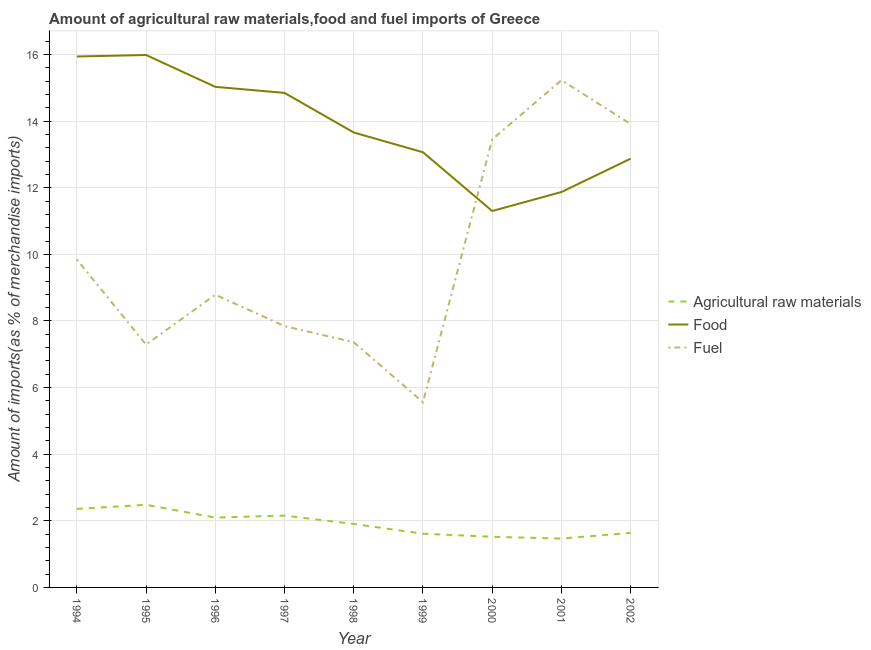What is the percentage of raw materials imports in 1998?
Offer a very short reply. 1.91. Across all years, what is the maximum percentage of raw materials imports?
Keep it short and to the point. 2.48. Across all years, what is the minimum percentage of food imports?
Provide a succinct answer. 11.3. In which year was the percentage of fuel imports maximum?
Keep it short and to the point. 2001. What is the total percentage of raw materials imports in the graph?
Your answer should be compact. 17.24. What is the difference between the percentage of raw materials imports in 1998 and that in 2002?
Your answer should be very brief. 0.27. What is the difference between the percentage of raw materials imports in 1994 and the percentage of fuel imports in 1998?
Your answer should be very brief. -5. What is the average percentage of food imports per year?
Offer a terse response. 13.84. In the year 1997, what is the difference between the percentage of raw materials imports and percentage of fuel imports?
Offer a terse response. -5.69. In how many years, is the percentage of raw materials imports greater than 0.4 %?
Your answer should be very brief. 9. What is the ratio of the percentage of fuel imports in 1996 to that in 2000?
Your answer should be very brief. 0.65. Is the difference between the percentage of raw materials imports in 1998 and 2000 greater than the difference between the percentage of fuel imports in 1998 and 2000?
Give a very brief answer. Yes. What is the difference between the highest and the second highest percentage of fuel imports?
Ensure brevity in your answer.  1.31. What is the difference between the highest and the lowest percentage of food imports?
Your answer should be very brief. 4.68. Is the sum of the percentage of food imports in 1994 and 1997 greater than the maximum percentage of raw materials imports across all years?
Give a very brief answer. Yes. Is the percentage of fuel imports strictly less than the percentage of raw materials imports over the years?
Offer a terse response. No. What is the difference between two consecutive major ticks on the Y-axis?
Keep it short and to the point. 2. Where does the legend appear in the graph?
Keep it short and to the point. Center right. How many legend labels are there?
Give a very brief answer. 3. What is the title of the graph?
Give a very brief answer. Amount of agricultural raw materials,food and fuel imports of Greece. What is the label or title of the X-axis?
Offer a very short reply. Year. What is the label or title of the Y-axis?
Offer a very short reply. Amount of imports(as % of merchandise imports). What is the Amount of imports(as % of merchandise imports) of Agricultural raw materials in 1994?
Offer a terse response. 2.36. What is the Amount of imports(as % of merchandise imports) of Food in 1994?
Make the answer very short. 15.94. What is the Amount of imports(as % of merchandise imports) of Fuel in 1994?
Give a very brief answer. 9.85. What is the Amount of imports(as % of merchandise imports) of Agricultural raw materials in 1995?
Give a very brief answer. 2.48. What is the Amount of imports(as % of merchandise imports) in Food in 1995?
Make the answer very short. 15.99. What is the Amount of imports(as % of merchandise imports) of Fuel in 1995?
Offer a terse response. 7.29. What is the Amount of imports(as % of merchandise imports) of Agricultural raw materials in 1996?
Your response must be concise. 2.1. What is the Amount of imports(as % of merchandise imports) in Food in 1996?
Keep it short and to the point. 15.03. What is the Amount of imports(as % of merchandise imports) in Fuel in 1996?
Provide a succinct answer. 8.79. What is the Amount of imports(as % of merchandise imports) of Agricultural raw materials in 1997?
Make the answer very short. 2.16. What is the Amount of imports(as % of merchandise imports) of Food in 1997?
Your response must be concise. 14.85. What is the Amount of imports(as % of merchandise imports) in Fuel in 1997?
Offer a terse response. 7.85. What is the Amount of imports(as % of merchandise imports) of Agricultural raw materials in 1998?
Give a very brief answer. 1.91. What is the Amount of imports(as % of merchandise imports) of Food in 1998?
Give a very brief answer. 13.66. What is the Amount of imports(as % of merchandise imports) of Fuel in 1998?
Ensure brevity in your answer.  7.36. What is the Amount of imports(as % of merchandise imports) of Agricultural raw materials in 1999?
Your answer should be very brief. 1.61. What is the Amount of imports(as % of merchandise imports) of Food in 1999?
Provide a short and direct response. 13.07. What is the Amount of imports(as % of merchandise imports) in Fuel in 1999?
Your answer should be compact. 5.56. What is the Amount of imports(as % of merchandise imports) in Agricultural raw materials in 2000?
Provide a succinct answer. 1.52. What is the Amount of imports(as % of merchandise imports) in Food in 2000?
Your answer should be compact. 11.3. What is the Amount of imports(as % of merchandise imports) of Fuel in 2000?
Provide a succinct answer. 13.45. What is the Amount of imports(as % of merchandise imports) in Agricultural raw materials in 2001?
Your response must be concise. 1.47. What is the Amount of imports(as % of merchandise imports) in Food in 2001?
Make the answer very short. 11.87. What is the Amount of imports(as % of merchandise imports) in Fuel in 2001?
Your response must be concise. 15.23. What is the Amount of imports(as % of merchandise imports) in Agricultural raw materials in 2002?
Your response must be concise. 1.64. What is the Amount of imports(as % of merchandise imports) of Food in 2002?
Your answer should be compact. 12.87. What is the Amount of imports(as % of merchandise imports) in Fuel in 2002?
Ensure brevity in your answer.  13.91. Across all years, what is the maximum Amount of imports(as % of merchandise imports) in Agricultural raw materials?
Your answer should be very brief. 2.48. Across all years, what is the maximum Amount of imports(as % of merchandise imports) of Food?
Offer a very short reply. 15.99. Across all years, what is the maximum Amount of imports(as % of merchandise imports) of Fuel?
Provide a short and direct response. 15.23. Across all years, what is the minimum Amount of imports(as % of merchandise imports) of Agricultural raw materials?
Keep it short and to the point. 1.47. Across all years, what is the minimum Amount of imports(as % of merchandise imports) in Food?
Your answer should be compact. 11.3. Across all years, what is the minimum Amount of imports(as % of merchandise imports) in Fuel?
Your answer should be very brief. 5.56. What is the total Amount of imports(as % of merchandise imports) of Agricultural raw materials in the graph?
Your answer should be very brief. 17.24. What is the total Amount of imports(as % of merchandise imports) of Food in the graph?
Your answer should be very brief. 124.58. What is the total Amount of imports(as % of merchandise imports) of Fuel in the graph?
Your answer should be compact. 89.29. What is the difference between the Amount of imports(as % of merchandise imports) of Agricultural raw materials in 1994 and that in 1995?
Make the answer very short. -0.12. What is the difference between the Amount of imports(as % of merchandise imports) in Food in 1994 and that in 1995?
Your response must be concise. -0.04. What is the difference between the Amount of imports(as % of merchandise imports) of Fuel in 1994 and that in 1995?
Ensure brevity in your answer.  2.56. What is the difference between the Amount of imports(as % of merchandise imports) in Agricultural raw materials in 1994 and that in 1996?
Give a very brief answer. 0.26. What is the difference between the Amount of imports(as % of merchandise imports) of Food in 1994 and that in 1996?
Your response must be concise. 0.91. What is the difference between the Amount of imports(as % of merchandise imports) of Fuel in 1994 and that in 1996?
Make the answer very short. 1.06. What is the difference between the Amount of imports(as % of merchandise imports) of Agricultural raw materials in 1994 and that in 1997?
Provide a short and direct response. 0.2. What is the difference between the Amount of imports(as % of merchandise imports) in Food in 1994 and that in 1997?
Your answer should be compact. 1.09. What is the difference between the Amount of imports(as % of merchandise imports) in Fuel in 1994 and that in 1997?
Your answer should be very brief. 2. What is the difference between the Amount of imports(as % of merchandise imports) of Agricultural raw materials in 1994 and that in 1998?
Your response must be concise. 0.45. What is the difference between the Amount of imports(as % of merchandise imports) in Food in 1994 and that in 1998?
Your answer should be compact. 2.28. What is the difference between the Amount of imports(as % of merchandise imports) in Fuel in 1994 and that in 1998?
Ensure brevity in your answer.  2.49. What is the difference between the Amount of imports(as % of merchandise imports) of Agricultural raw materials in 1994 and that in 1999?
Make the answer very short. 0.74. What is the difference between the Amount of imports(as % of merchandise imports) of Food in 1994 and that in 1999?
Your answer should be very brief. 2.87. What is the difference between the Amount of imports(as % of merchandise imports) in Fuel in 1994 and that in 1999?
Make the answer very short. 4.29. What is the difference between the Amount of imports(as % of merchandise imports) in Agricultural raw materials in 1994 and that in 2000?
Provide a short and direct response. 0.84. What is the difference between the Amount of imports(as % of merchandise imports) of Food in 1994 and that in 2000?
Give a very brief answer. 4.64. What is the difference between the Amount of imports(as % of merchandise imports) in Fuel in 1994 and that in 2000?
Ensure brevity in your answer.  -3.6. What is the difference between the Amount of imports(as % of merchandise imports) of Agricultural raw materials in 1994 and that in 2001?
Keep it short and to the point. 0.89. What is the difference between the Amount of imports(as % of merchandise imports) in Food in 1994 and that in 2001?
Offer a very short reply. 4.07. What is the difference between the Amount of imports(as % of merchandise imports) in Fuel in 1994 and that in 2001?
Provide a succinct answer. -5.38. What is the difference between the Amount of imports(as % of merchandise imports) of Agricultural raw materials in 1994 and that in 2002?
Provide a short and direct response. 0.72. What is the difference between the Amount of imports(as % of merchandise imports) of Food in 1994 and that in 2002?
Provide a short and direct response. 3.07. What is the difference between the Amount of imports(as % of merchandise imports) in Fuel in 1994 and that in 2002?
Your response must be concise. -4.07. What is the difference between the Amount of imports(as % of merchandise imports) in Agricultural raw materials in 1995 and that in 1996?
Your answer should be very brief. 0.39. What is the difference between the Amount of imports(as % of merchandise imports) of Food in 1995 and that in 1996?
Your answer should be compact. 0.96. What is the difference between the Amount of imports(as % of merchandise imports) of Fuel in 1995 and that in 1996?
Keep it short and to the point. -1.5. What is the difference between the Amount of imports(as % of merchandise imports) of Agricultural raw materials in 1995 and that in 1997?
Offer a terse response. 0.32. What is the difference between the Amount of imports(as % of merchandise imports) in Food in 1995 and that in 1997?
Offer a terse response. 1.14. What is the difference between the Amount of imports(as % of merchandise imports) of Fuel in 1995 and that in 1997?
Your answer should be compact. -0.56. What is the difference between the Amount of imports(as % of merchandise imports) in Agricultural raw materials in 1995 and that in 1998?
Offer a terse response. 0.58. What is the difference between the Amount of imports(as % of merchandise imports) of Food in 1995 and that in 1998?
Offer a terse response. 2.33. What is the difference between the Amount of imports(as % of merchandise imports) of Fuel in 1995 and that in 1998?
Make the answer very short. -0.07. What is the difference between the Amount of imports(as % of merchandise imports) of Agricultural raw materials in 1995 and that in 1999?
Offer a very short reply. 0.87. What is the difference between the Amount of imports(as % of merchandise imports) in Food in 1995 and that in 1999?
Your answer should be very brief. 2.92. What is the difference between the Amount of imports(as % of merchandise imports) in Fuel in 1995 and that in 1999?
Your answer should be very brief. 1.73. What is the difference between the Amount of imports(as % of merchandise imports) of Agricultural raw materials in 1995 and that in 2000?
Your answer should be compact. 0.96. What is the difference between the Amount of imports(as % of merchandise imports) in Food in 1995 and that in 2000?
Your answer should be very brief. 4.68. What is the difference between the Amount of imports(as % of merchandise imports) of Fuel in 1995 and that in 2000?
Provide a succinct answer. -6.16. What is the difference between the Amount of imports(as % of merchandise imports) of Agricultural raw materials in 1995 and that in 2001?
Your answer should be compact. 1.01. What is the difference between the Amount of imports(as % of merchandise imports) of Food in 1995 and that in 2001?
Your answer should be compact. 4.11. What is the difference between the Amount of imports(as % of merchandise imports) of Fuel in 1995 and that in 2001?
Your response must be concise. -7.94. What is the difference between the Amount of imports(as % of merchandise imports) in Agricultural raw materials in 1995 and that in 2002?
Offer a very short reply. 0.84. What is the difference between the Amount of imports(as % of merchandise imports) of Food in 1995 and that in 2002?
Your answer should be compact. 3.11. What is the difference between the Amount of imports(as % of merchandise imports) of Fuel in 1995 and that in 2002?
Your response must be concise. -6.62. What is the difference between the Amount of imports(as % of merchandise imports) in Agricultural raw materials in 1996 and that in 1997?
Provide a succinct answer. -0.06. What is the difference between the Amount of imports(as % of merchandise imports) in Food in 1996 and that in 1997?
Your answer should be compact. 0.18. What is the difference between the Amount of imports(as % of merchandise imports) in Fuel in 1996 and that in 1997?
Offer a very short reply. 0.94. What is the difference between the Amount of imports(as % of merchandise imports) in Agricultural raw materials in 1996 and that in 1998?
Provide a succinct answer. 0.19. What is the difference between the Amount of imports(as % of merchandise imports) of Food in 1996 and that in 1998?
Your answer should be very brief. 1.37. What is the difference between the Amount of imports(as % of merchandise imports) of Fuel in 1996 and that in 1998?
Your answer should be very brief. 1.43. What is the difference between the Amount of imports(as % of merchandise imports) in Agricultural raw materials in 1996 and that in 1999?
Offer a terse response. 0.48. What is the difference between the Amount of imports(as % of merchandise imports) in Food in 1996 and that in 1999?
Your response must be concise. 1.96. What is the difference between the Amount of imports(as % of merchandise imports) in Fuel in 1996 and that in 1999?
Your answer should be very brief. 3.23. What is the difference between the Amount of imports(as % of merchandise imports) of Agricultural raw materials in 1996 and that in 2000?
Your answer should be very brief. 0.58. What is the difference between the Amount of imports(as % of merchandise imports) of Food in 1996 and that in 2000?
Ensure brevity in your answer.  3.73. What is the difference between the Amount of imports(as % of merchandise imports) in Fuel in 1996 and that in 2000?
Make the answer very short. -4.66. What is the difference between the Amount of imports(as % of merchandise imports) of Agricultural raw materials in 1996 and that in 2001?
Your answer should be very brief. 0.63. What is the difference between the Amount of imports(as % of merchandise imports) of Food in 1996 and that in 2001?
Ensure brevity in your answer.  3.16. What is the difference between the Amount of imports(as % of merchandise imports) in Fuel in 1996 and that in 2001?
Offer a very short reply. -6.44. What is the difference between the Amount of imports(as % of merchandise imports) in Agricultural raw materials in 1996 and that in 2002?
Ensure brevity in your answer.  0.46. What is the difference between the Amount of imports(as % of merchandise imports) of Food in 1996 and that in 2002?
Provide a succinct answer. 2.16. What is the difference between the Amount of imports(as % of merchandise imports) in Fuel in 1996 and that in 2002?
Your response must be concise. -5.12. What is the difference between the Amount of imports(as % of merchandise imports) in Agricultural raw materials in 1997 and that in 1998?
Offer a very short reply. 0.25. What is the difference between the Amount of imports(as % of merchandise imports) in Food in 1997 and that in 1998?
Your answer should be compact. 1.19. What is the difference between the Amount of imports(as % of merchandise imports) of Fuel in 1997 and that in 1998?
Your answer should be very brief. 0.48. What is the difference between the Amount of imports(as % of merchandise imports) of Agricultural raw materials in 1997 and that in 1999?
Offer a terse response. 0.54. What is the difference between the Amount of imports(as % of merchandise imports) of Food in 1997 and that in 1999?
Provide a short and direct response. 1.78. What is the difference between the Amount of imports(as % of merchandise imports) in Fuel in 1997 and that in 1999?
Your response must be concise. 2.29. What is the difference between the Amount of imports(as % of merchandise imports) of Agricultural raw materials in 1997 and that in 2000?
Offer a very short reply. 0.64. What is the difference between the Amount of imports(as % of merchandise imports) of Food in 1997 and that in 2000?
Keep it short and to the point. 3.55. What is the difference between the Amount of imports(as % of merchandise imports) in Fuel in 1997 and that in 2000?
Provide a short and direct response. -5.61. What is the difference between the Amount of imports(as % of merchandise imports) in Agricultural raw materials in 1997 and that in 2001?
Your answer should be compact. 0.69. What is the difference between the Amount of imports(as % of merchandise imports) of Food in 1997 and that in 2001?
Ensure brevity in your answer.  2.98. What is the difference between the Amount of imports(as % of merchandise imports) in Fuel in 1997 and that in 2001?
Make the answer very short. -7.38. What is the difference between the Amount of imports(as % of merchandise imports) of Agricultural raw materials in 1997 and that in 2002?
Ensure brevity in your answer.  0.52. What is the difference between the Amount of imports(as % of merchandise imports) in Food in 1997 and that in 2002?
Your answer should be compact. 1.97. What is the difference between the Amount of imports(as % of merchandise imports) in Fuel in 1997 and that in 2002?
Your answer should be very brief. -6.07. What is the difference between the Amount of imports(as % of merchandise imports) in Agricultural raw materials in 1998 and that in 1999?
Offer a terse response. 0.29. What is the difference between the Amount of imports(as % of merchandise imports) in Food in 1998 and that in 1999?
Make the answer very short. 0.59. What is the difference between the Amount of imports(as % of merchandise imports) of Fuel in 1998 and that in 1999?
Your response must be concise. 1.8. What is the difference between the Amount of imports(as % of merchandise imports) of Agricultural raw materials in 1998 and that in 2000?
Offer a terse response. 0.38. What is the difference between the Amount of imports(as % of merchandise imports) of Food in 1998 and that in 2000?
Provide a short and direct response. 2.36. What is the difference between the Amount of imports(as % of merchandise imports) of Fuel in 1998 and that in 2000?
Your answer should be very brief. -6.09. What is the difference between the Amount of imports(as % of merchandise imports) in Agricultural raw materials in 1998 and that in 2001?
Provide a succinct answer. 0.44. What is the difference between the Amount of imports(as % of merchandise imports) in Food in 1998 and that in 2001?
Your answer should be compact. 1.79. What is the difference between the Amount of imports(as % of merchandise imports) in Fuel in 1998 and that in 2001?
Your answer should be very brief. -7.87. What is the difference between the Amount of imports(as % of merchandise imports) of Agricultural raw materials in 1998 and that in 2002?
Provide a short and direct response. 0.27. What is the difference between the Amount of imports(as % of merchandise imports) in Food in 1998 and that in 2002?
Keep it short and to the point. 0.79. What is the difference between the Amount of imports(as % of merchandise imports) in Fuel in 1998 and that in 2002?
Your response must be concise. -6.55. What is the difference between the Amount of imports(as % of merchandise imports) in Agricultural raw materials in 1999 and that in 2000?
Give a very brief answer. 0.09. What is the difference between the Amount of imports(as % of merchandise imports) in Food in 1999 and that in 2000?
Your response must be concise. 1.77. What is the difference between the Amount of imports(as % of merchandise imports) in Fuel in 1999 and that in 2000?
Give a very brief answer. -7.89. What is the difference between the Amount of imports(as % of merchandise imports) of Agricultural raw materials in 1999 and that in 2001?
Your response must be concise. 0.15. What is the difference between the Amount of imports(as % of merchandise imports) in Food in 1999 and that in 2001?
Your answer should be compact. 1.19. What is the difference between the Amount of imports(as % of merchandise imports) of Fuel in 1999 and that in 2001?
Give a very brief answer. -9.67. What is the difference between the Amount of imports(as % of merchandise imports) in Agricultural raw materials in 1999 and that in 2002?
Offer a terse response. -0.02. What is the difference between the Amount of imports(as % of merchandise imports) in Food in 1999 and that in 2002?
Make the answer very short. 0.19. What is the difference between the Amount of imports(as % of merchandise imports) in Fuel in 1999 and that in 2002?
Your response must be concise. -8.36. What is the difference between the Amount of imports(as % of merchandise imports) in Agricultural raw materials in 2000 and that in 2001?
Ensure brevity in your answer.  0.05. What is the difference between the Amount of imports(as % of merchandise imports) in Food in 2000 and that in 2001?
Your response must be concise. -0.57. What is the difference between the Amount of imports(as % of merchandise imports) in Fuel in 2000 and that in 2001?
Provide a short and direct response. -1.78. What is the difference between the Amount of imports(as % of merchandise imports) of Agricultural raw materials in 2000 and that in 2002?
Ensure brevity in your answer.  -0.12. What is the difference between the Amount of imports(as % of merchandise imports) of Food in 2000 and that in 2002?
Make the answer very short. -1.57. What is the difference between the Amount of imports(as % of merchandise imports) in Fuel in 2000 and that in 2002?
Your answer should be very brief. -0.46. What is the difference between the Amount of imports(as % of merchandise imports) of Agricultural raw materials in 2001 and that in 2002?
Provide a short and direct response. -0.17. What is the difference between the Amount of imports(as % of merchandise imports) of Food in 2001 and that in 2002?
Make the answer very short. -1. What is the difference between the Amount of imports(as % of merchandise imports) of Fuel in 2001 and that in 2002?
Keep it short and to the point. 1.31. What is the difference between the Amount of imports(as % of merchandise imports) in Agricultural raw materials in 1994 and the Amount of imports(as % of merchandise imports) in Food in 1995?
Provide a short and direct response. -13.63. What is the difference between the Amount of imports(as % of merchandise imports) in Agricultural raw materials in 1994 and the Amount of imports(as % of merchandise imports) in Fuel in 1995?
Your answer should be compact. -4.93. What is the difference between the Amount of imports(as % of merchandise imports) of Food in 1994 and the Amount of imports(as % of merchandise imports) of Fuel in 1995?
Give a very brief answer. 8.65. What is the difference between the Amount of imports(as % of merchandise imports) of Agricultural raw materials in 1994 and the Amount of imports(as % of merchandise imports) of Food in 1996?
Give a very brief answer. -12.67. What is the difference between the Amount of imports(as % of merchandise imports) of Agricultural raw materials in 1994 and the Amount of imports(as % of merchandise imports) of Fuel in 1996?
Your answer should be compact. -6.43. What is the difference between the Amount of imports(as % of merchandise imports) in Food in 1994 and the Amount of imports(as % of merchandise imports) in Fuel in 1996?
Your answer should be compact. 7.15. What is the difference between the Amount of imports(as % of merchandise imports) in Agricultural raw materials in 1994 and the Amount of imports(as % of merchandise imports) in Food in 1997?
Provide a succinct answer. -12.49. What is the difference between the Amount of imports(as % of merchandise imports) of Agricultural raw materials in 1994 and the Amount of imports(as % of merchandise imports) of Fuel in 1997?
Give a very brief answer. -5.49. What is the difference between the Amount of imports(as % of merchandise imports) in Food in 1994 and the Amount of imports(as % of merchandise imports) in Fuel in 1997?
Your response must be concise. 8.1. What is the difference between the Amount of imports(as % of merchandise imports) of Agricultural raw materials in 1994 and the Amount of imports(as % of merchandise imports) of Food in 1998?
Provide a short and direct response. -11.3. What is the difference between the Amount of imports(as % of merchandise imports) of Agricultural raw materials in 1994 and the Amount of imports(as % of merchandise imports) of Fuel in 1998?
Offer a very short reply. -5. What is the difference between the Amount of imports(as % of merchandise imports) of Food in 1994 and the Amount of imports(as % of merchandise imports) of Fuel in 1998?
Give a very brief answer. 8.58. What is the difference between the Amount of imports(as % of merchandise imports) in Agricultural raw materials in 1994 and the Amount of imports(as % of merchandise imports) in Food in 1999?
Your answer should be very brief. -10.71. What is the difference between the Amount of imports(as % of merchandise imports) of Agricultural raw materials in 1994 and the Amount of imports(as % of merchandise imports) of Fuel in 1999?
Keep it short and to the point. -3.2. What is the difference between the Amount of imports(as % of merchandise imports) of Food in 1994 and the Amount of imports(as % of merchandise imports) of Fuel in 1999?
Keep it short and to the point. 10.38. What is the difference between the Amount of imports(as % of merchandise imports) in Agricultural raw materials in 1994 and the Amount of imports(as % of merchandise imports) in Food in 2000?
Make the answer very short. -8.94. What is the difference between the Amount of imports(as % of merchandise imports) in Agricultural raw materials in 1994 and the Amount of imports(as % of merchandise imports) in Fuel in 2000?
Your answer should be very brief. -11.1. What is the difference between the Amount of imports(as % of merchandise imports) in Food in 1994 and the Amount of imports(as % of merchandise imports) in Fuel in 2000?
Offer a terse response. 2.49. What is the difference between the Amount of imports(as % of merchandise imports) in Agricultural raw materials in 1994 and the Amount of imports(as % of merchandise imports) in Food in 2001?
Your answer should be very brief. -9.52. What is the difference between the Amount of imports(as % of merchandise imports) in Agricultural raw materials in 1994 and the Amount of imports(as % of merchandise imports) in Fuel in 2001?
Your response must be concise. -12.87. What is the difference between the Amount of imports(as % of merchandise imports) in Food in 1994 and the Amount of imports(as % of merchandise imports) in Fuel in 2001?
Your answer should be very brief. 0.71. What is the difference between the Amount of imports(as % of merchandise imports) of Agricultural raw materials in 1994 and the Amount of imports(as % of merchandise imports) of Food in 2002?
Offer a terse response. -10.52. What is the difference between the Amount of imports(as % of merchandise imports) of Agricultural raw materials in 1994 and the Amount of imports(as % of merchandise imports) of Fuel in 2002?
Offer a very short reply. -11.56. What is the difference between the Amount of imports(as % of merchandise imports) of Food in 1994 and the Amount of imports(as % of merchandise imports) of Fuel in 2002?
Give a very brief answer. 2.03. What is the difference between the Amount of imports(as % of merchandise imports) in Agricultural raw materials in 1995 and the Amount of imports(as % of merchandise imports) in Food in 1996?
Provide a succinct answer. -12.55. What is the difference between the Amount of imports(as % of merchandise imports) of Agricultural raw materials in 1995 and the Amount of imports(as % of merchandise imports) of Fuel in 1996?
Make the answer very short. -6.31. What is the difference between the Amount of imports(as % of merchandise imports) of Food in 1995 and the Amount of imports(as % of merchandise imports) of Fuel in 1996?
Ensure brevity in your answer.  7.2. What is the difference between the Amount of imports(as % of merchandise imports) in Agricultural raw materials in 1995 and the Amount of imports(as % of merchandise imports) in Food in 1997?
Give a very brief answer. -12.37. What is the difference between the Amount of imports(as % of merchandise imports) of Agricultural raw materials in 1995 and the Amount of imports(as % of merchandise imports) of Fuel in 1997?
Provide a succinct answer. -5.36. What is the difference between the Amount of imports(as % of merchandise imports) of Food in 1995 and the Amount of imports(as % of merchandise imports) of Fuel in 1997?
Offer a terse response. 8.14. What is the difference between the Amount of imports(as % of merchandise imports) of Agricultural raw materials in 1995 and the Amount of imports(as % of merchandise imports) of Food in 1998?
Your response must be concise. -11.18. What is the difference between the Amount of imports(as % of merchandise imports) of Agricultural raw materials in 1995 and the Amount of imports(as % of merchandise imports) of Fuel in 1998?
Make the answer very short. -4.88. What is the difference between the Amount of imports(as % of merchandise imports) in Food in 1995 and the Amount of imports(as % of merchandise imports) in Fuel in 1998?
Give a very brief answer. 8.62. What is the difference between the Amount of imports(as % of merchandise imports) of Agricultural raw materials in 1995 and the Amount of imports(as % of merchandise imports) of Food in 1999?
Your answer should be compact. -10.58. What is the difference between the Amount of imports(as % of merchandise imports) in Agricultural raw materials in 1995 and the Amount of imports(as % of merchandise imports) in Fuel in 1999?
Offer a very short reply. -3.08. What is the difference between the Amount of imports(as % of merchandise imports) of Food in 1995 and the Amount of imports(as % of merchandise imports) of Fuel in 1999?
Provide a succinct answer. 10.43. What is the difference between the Amount of imports(as % of merchandise imports) of Agricultural raw materials in 1995 and the Amount of imports(as % of merchandise imports) of Food in 2000?
Make the answer very short. -8.82. What is the difference between the Amount of imports(as % of merchandise imports) in Agricultural raw materials in 1995 and the Amount of imports(as % of merchandise imports) in Fuel in 2000?
Make the answer very short. -10.97. What is the difference between the Amount of imports(as % of merchandise imports) in Food in 1995 and the Amount of imports(as % of merchandise imports) in Fuel in 2000?
Offer a very short reply. 2.53. What is the difference between the Amount of imports(as % of merchandise imports) in Agricultural raw materials in 1995 and the Amount of imports(as % of merchandise imports) in Food in 2001?
Your answer should be compact. -9.39. What is the difference between the Amount of imports(as % of merchandise imports) of Agricultural raw materials in 1995 and the Amount of imports(as % of merchandise imports) of Fuel in 2001?
Provide a succinct answer. -12.75. What is the difference between the Amount of imports(as % of merchandise imports) in Food in 1995 and the Amount of imports(as % of merchandise imports) in Fuel in 2001?
Provide a short and direct response. 0.76. What is the difference between the Amount of imports(as % of merchandise imports) in Agricultural raw materials in 1995 and the Amount of imports(as % of merchandise imports) in Food in 2002?
Ensure brevity in your answer.  -10.39. What is the difference between the Amount of imports(as % of merchandise imports) in Agricultural raw materials in 1995 and the Amount of imports(as % of merchandise imports) in Fuel in 2002?
Provide a short and direct response. -11.43. What is the difference between the Amount of imports(as % of merchandise imports) of Food in 1995 and the Amount of imports(as % of merchandise imports) of Fuel in 2002?
Your answer should be compact. 2.07. What is the difference between the Amount of imports(as % of merchandise imports) in Agricultural raw materials in 1996 and the Amount of imports(as % of merchandise imports) in Food in 1997?
Provide a short and direct response. -12.75. What is the difference between the Amount of imports(as % of merchandise imports) in Agricultural raw materials in 1996 and the Amount of imports(as % of merchandise imports) in Fuel in 1997?
Keep it short and to the point. -5.75. What is the difference between the Amount of imports(as % of merchandise imports) in Food in 1996 and the Amount of imports(as % of merchandise imports) in Fuel in 1997?
Your answer should be very brief. 7.18. What is the difference between the Amount of imports(as % of merchandise imports) of Agricultural raw materials in 1996 and the Amount of imports(as % of merchandise imports) of Food in 1998?
Offer a terse response. -11.56. What is the difference between the Amount of imports(as % of merchandise imports) of Agricultural raw materials in 1996 and the Amount of imports(as % of merchandise imports) of Fuel in 1998?
Provide a short and direct response. -5.26. What is the difference between the Amount of imports(as % of merchandise imports) of Food in 1996 and the Amount of imports(as % of merchandise imports) of Fuel in 1998?
Keep it short and to the point. 7.67. What is the difference between the Amount of imports(as % of merchandise imports) in Agricultural raw materials in 1996 and the Amount of imports(as % of merchandise imports) in Food in 1999?
Your answer should be very brief. -10.97. What is the difference between the Amount of imports(as % of merchandise imports) in Agricultural raw materials in 1996 and the Amount of imports(as % of merchandise imports) in Fuel in 1999?
Offer a very short reply. -3.46. What is the difference between the Amount of imports(as % of merchandise imports) of Food in 1996 and the Amount of imports(as % of merchandise imports) of Fuel in 1999?
Your response must be concise. 9.47. What is the difference between the Amount of imports(as % of merchandise imports) in Agricultural raw materials in 1996 and the Amount of imports(as % of merchandise imports) in Food in 2000?
Your answer should be very brief. -9.2. What is the difference between the Amount of imports(as % of merchandise imports) of Agricultural raw materials in 1996 and the Amount of imports(as % of merchandise imports) of Fuel in 2000?
Give a very brief answer. -11.36. What is the difference between the Amount of imports(as % of merchandise imports) in Food in 1996 and the Amount of imports(as % of merchandise imports) in Fuel in 2000?
Provide a short and direct response. 1.58. What is the difference between the Amount of imports(as % of merchandise imports) in Agricultural raw materials in 1996 and the Amount of imports(as % of merchandise imports) in Food in 2001?
Give a very brief answer. -9.78. What is the difference between the Amount of imports(as % of merchandise imports) of Agricultural raw materials in 1996 and the Amount of imports(as % of merchandise imports) of Fuel in 2001?
Ensure brevity in your answer.  -13.13. What is the difference between the Amount of imports(as % of merchandise imports) of Food in 1996 and the Amount of imports(as % of merchandise imports) of Fuel in 2001?
Ensure brevity in your answer.  -0.2. What is the difference between the Amount of imports(as % of merchandise imports) in Agricultural raw materials in 1996 and the Amount of imports(as % of merchandise imports) in Food in 2002?
Make the answer very short. -10.78. What is the difference between the Amount of imports(as % of merchandise imports) in Agricultural raw materials in 1996 and the Amount of imports(as % of merchandise imports) in Fuel in 2002?
Keep it short and to the point. -11.82. What is the difference between the Amount of imports(as % of merchandise imports) in Food in 1996 and the Amount of imports(as % of merchandise imports) in Fuel in 2002?
Make the answer very short. 1.12. What is the difference between the Amount of imports(as % of merchandise imports) in Agricultural raw materials in 1997 and the Amount of imports(as % of merchandise imports) in Food in 1998?
Offer a very short reply. -11.5. What is the difference between the Amount of imports(as % of merchandise imports) in Agricultural raw materials in 1997 and the Amount of imports(as % of merchandise imports) in Fuel in 1998?
Your response must be concise. -5.2. What is the difference between the Amount of imports(as % of merchandise imports) in Food in 1997 and the Amount of imports(as % of merchandise imports) in Fuel in 1998?
Provide a short and direct response. 7.49. What is the difference between the Amount of imports(as % of merchandise imports) in Agricultural raw materials in 1997 and the Amount of imports(as % of merchandise imports) in Food in 1999?
Make the answer very short. -10.91. What is the difference between the Amount of imports(as % of merchandise imports) in Agricultural raw materials in 1997 and the Amount of imports(as % of merchandise imports) in Fuel in 1999?
Make the answer very short. -3.4. What is the difference between the Amount of imports(as % of merchandise imports) in Food in 1997 and the Amount of imports(as % of merchandise imports) in Fuel in 1999?
Your response must be concise. 9.29. What is the difference between the Amount of imports(as % of merchandise imports) in Agricultural raw materials in 1997 and the Amount of imports(as % of merchandise imports) in Food in 2000?
Your answer should be very brief. -9.14. What is the difference between the Amount of imports(as % of merchandise imports) of Agricultural raw materials in 1997 and the Amount of imports(as % of merchandise imports) of Fuel in 2000?
Ensure brevity in your answer.  -11.3. What is the difference between the Amount of imports(as % of merchandise imports) in Food in 1997 and the Amount of imports(as % of merchandise imports) in Fuel in 2000?
Your response must be concise. 1.4. What is the difference between the Amount of imports(as % of merchandise imports) of Agricultural raw materials in 1997 and the Amount of imports(as % of merchandise imports) of Food in 2001?
Your answer should be compact. -9.72. What is the difference between the Amount of imports(as % of merchandise imports) in Agricultural raw materials in 1997 and the Amount of imports(as % of merchandise imports) in Fuel in 2001?
Your answer should be compact. -13.07. What is the difference between the Amount of imports(as % of merchandise imports) in Food in 1997 and the Amount of imports(as % of merchandise imports) in Fuel in 2001?
Your answer should be compact. -0.38. What is the difference between the Amount of imports(as % of merchandise imports) of Agricultural raw materials in 1997 and the Amount of imports(as % of merchandise imports) of Food in 2002?
Your response must be concise. -10.72. What is the difference between the Amount of imports(as % of merchandise imports) in Agricultural raw materials in 1997 and the Amount of imports(as % of merchandise imports) in Fuel in 2002?
Provide a succinct answer. -11.76. What is the difference between the Amount of imports(as % of merchandise imports) of Food in 1997 and the Amount of imports(as % of merchandise imports) of Fuel in 2002?
Offer a terse response. 0.93. What is the difference between the Amount of imports(as % of merchandise imports) in Agricultural raw materials in 1998 and the Amount of imports(as % of merchandise imports) in Food in 1999?
Your response must be concise. -11.16. What is the difference between the Amount of imports(as % of merchandise imports) in Agricultural raw materials in 1998 and the Amount of imports(as % of merchandise imports) in Fuel in 1999?
Provide a short and direct response. -3.65. What is the difference between the Amount of imports(as % of merchandise imports) in Food in 1998 and the Amount of imports(as % of merchandise imports) in Fuel in 1999?
Your answer should be compact. 8.1. What is the difference between the Amount of imports(as % of merchandise imports) in Agricultural raw materials in 1998 and the Amount of imports(as % of merchandise imports) in Food in 2000?
Offer a very short reply. -9.4. What is the difference between the Amount of imports(as % of merchandise imports) in Agricultural raw materials in 1998 and the Amount of imports(as % of merchandise imports) in Fuel in 2000?
Provide a short and direct response. -11.55. What is the difference between the Amount of imports(as % of merchandise imports) in Food in 1998 and the Amount of imports(as % of merchandise imports) in Fuel in 2000?
Make the answer very short. 0.21. What is the difference between the Amount of imports(as % of merchandise imports) in Agricultural raw materials in 1998 and the Amount of imports(as % of merchandise imports) in Food in 2001?
Provide a short and direct response. -9.97. What is the difference between the Amount of imports(as % of merchandise imports) of Agricultural raw materials in 1998 and the Amount of imports(as % of merchandise imports) of Fuel in 2001?
Your answer should be compact. -13.32. What is the difference between the Amount of imports(as % of merchandise imports) in Food in 1998 and the Amount of imports(as % of merchandise imports) in Fuel in 2001?
Provide a succinct answer. -1.57. What is the difference between the Amount of imports(as % of merchandise imports) of Agricultural raw materials in 1998 and the Amount of imports(as % of merchandise imports) of Food in 2002?
Your response must be concise. -10.97. What is the difference between the Amount of imports(as % of merchandise imports) of Agricultural raw materials in 1998 and the Amount of imports(as % of merchandise imports) of Fuel in 2002?
Provide a short and direct response. -12.01. What is the difference between the Amount of imports(as % of merchandise imports) in Food in 1998 and the Amount of imports(as % of merchandise imports) in Fuel in 2002?
Keep it short and to the point. -0.25. What is the difference between the Amount of imports(as % of merchandise imports) of Agricultural raw materials in 1999 and the Amount of imports(as % of merchandise imports) of Food in 2000?
Offer a terse response. -9.69. What is the difference between the Amount of imports(as % of merchandise imports) of Agricultural raw materials in 1999 and the Amount of imports(as % of merchandise imports) of Fuel in 2000?
Provide a short and direct response. -11.84. What is the difference between the Amount of imports(as % of merchandise imports) in Food in 1999 and the Amount of imports(as % of merchandise imports) in Fuel in 2000?
Keep it short and to the point. -0.39. What is the difference between the Amount of imports(as % of merchandise imports) in Agricultural raw materials in 1999 and the Amount of imports(as % of merchandise imports) in Food in 2001?
Make the answer very short. -10.26. What is the difference between the Amount of imports(as % of merchandise imports) in Agricultural raw materials in 1999 and the Amount of imports(as % of merchandise imports) in Fuel in 2001?
Your answer should be very brief. -13.62. What is the difference between the Amount of imports(as % of merchandise imports) in Food in 1999 and the Amount of imports(as % of merchandise imports) in Fuel in 2001?
Provide a succinct answer. -2.16. What is the difference between the Amount of imports(as % of merchandise imports) of Agricultural raw materials in 1999 and the Amount of imports(as % of merchandise imports) of Food in 2002?
Offer a very short reply. -11.26. What is the difference between the Amount of imports(as % of merchandise imports) of Agricultural raw materials in 1999 and the Amount of imports(as % of merchandise imports) of Fuel in 2002?
Give a very brief answer. -12.3. What is the difference between the Amount of imports(as % of merchandise imports) in Food in 1999 and the Amount of imports(as % of merchandise imports) in Fuel in 2002?
Ensure brevity in your answer.  -0.85. What is the difference between the Amount of imports(as % of merchandise imports) of Agricultural raw materials in 2000 and the Amount of imports(as % of merchandise imports) of Food in 2001?
Offer a very short reply. -10.35. What is the difference between the Amount of imports(as % of merchandise imports) in Agricultural raw materials in 2000 and the Amount of imports(as % of merchandise imports) in Fuel in 2001?
Make the answer very short. -13.71. What is the difference between the Amount of imports(as % of merchandise imports) of Food in 2000 and the Amount of imports(as % of merchandise imports) of Fuel in 2001?
Provide a succinct answer. -3.93. What is the difference between the Amount of imports(as % of merchandise imports) of Agricultural raw materials in 2000 and the Amount of imports(as % of merchandise imports) of Food in 2002?
Give a very brief answer. -11.35. What is the difference between the Amount of imports(as % of merchandise imports) of Agricultural raw materials in 2000 and the Amount of imports(as % of merchandise imports) of Fuel in 2002?
Offer a terse response. -12.39. What is the difference between the Amount of imports(as % of merchandise imports) of Food in 2000 and the Amount of imports(as % of merchandise imports) of Fuel in 2002?
Your answer should be compact. -2.61. What is the difference between the Amount of imports(as % of merchandise imports) of Agricultural raw materials in 2001 and the Amount of imports(as % of merchandise imports) of Food in 2002?
Give a very brief answer. -11.41. What is the difference between the Amount of imports(as % of merchandise imports) in Agricultural raw materials in 2001 and the Amount of imports(as % of merchandise imports) in Fuel in 2002?
Provide a succinct answer. -12.45. What is the difference between the Amount of imports(as % of merchandise imports) in Food in 2001 and the Amount of imports(as % of merchandise imports) in Fuel in 2002?
Your answer should be very brief. -2.04. What is the average Amount of imports(as % of merchandise imports) in Agricultural raw materials per year?
Offer a terse response. 1.92. What is the average Amount of imports(as % of merchandise imports) in Food per year?
Provide a short and direct response. 13.84. What is the average Amount of imports(as % of merchandise imports) of Fuel per year?
Offer a very short reply. 9.92. In the year 1994, what is the difference between the Amount of imports(as % of merchandise imports) in Agricultural raw materials and Amount of imports(as % of merchandise imports) in Food?
Ensure brevity in your answer.  -13.58. In the year 1994, what is the difference between the Amount of imports(as % of merchandise imports) of Agricultural raw materials and Amount of imports(as % of merchandise imports) of Fuel?
Provide a short and direct response. -7.49. In the year 1994, what is the difference between the Amount of imports(as % of merchandise imports) in Food and Amount of imports(as % of merchandise imports) in Fuel?
Make the answer very short. 6.09. In the year 1995, what is the difference between the Amount of imports(as % of merchandise imports) of Agricultural raw materials and Amount of imports(as % of merchandise imports) of Food?
Your answer should be very brief. -13.5. In the year 1995, what is the difference between the Amount of imports(as % of merchandise imports) of Agricultural raw materials and Amount of imports(as % of merchandise imports) of Fuel?
Ensure brevity in your answer.  -4.81. In the year 1995, what is the difference between the Amount of imports(as % of merchandise imports) of Food and Amount of imports(as % of merchandise imports) of Fuel?
Offer a terse response. 8.7. In the year 1996, what is the difference between the Amount of imports(as % of merchandise imports) of Agricultural raw materials and Amount of imports(as % of merchandise imports) of Food?
Offer a very short reply. -12.93. In the year 1996, what is the difference between the Amount of imports(as % of merchandise imports) in Agricultural raw materials and Amount of imports(as % of merchandise imports) in Fuel?
Your answer should be compact. -6.69. In the year 1996, what is the difference between the Amount of imports(as % of merchandise imports) in Food and Amount of imports(as % of merchandise imports) in Fuel?
Give a very brief answer. 6.24. In the year 1997, what is the difference between the Amount of imports(as % of merchandise imports) of Agricultural raw materials and Amount of imports(as % of merchandise imports) of Food?
Your response must be concise. -12.69. In the year 1997, what is the difference between the Amount of imports(as % of merchandise imports) of Agricultural raw materials and Amount of imports(as % of merchandise imports) of Fuel?
Offer a terse response. -5.69. In the year 1997, what is the difference between the Amount of imports(as % of merchandise imports) in Food and Amount of imports(as % of merchandise imports) in Fuel?
Make the answer very short. 7. In the year 1998, what is the difference between the Amount of imports(as % of merchandise imports) of Agricultural raw materials and Amount of imports(as % of merchandise imports) of Food?
Your answer should be very brief. -11.75. In the year 1998, what is the difference between the Amount of imports(as % of merchandise imports) in Agricultural raw materials and Amount of imports(as % of merchandise imports) in Fuel?
Your answer should be very brief. -5.46. In the year 1998, what is the difference between the Amount of imports(as % of merchandise imports) in Food and Amount of imports(as % of merchandise imports) in Fuel?
Ensure brevity in your answer.  6.3. In the year 1999, what is the difference between the Amount of imports(as % of merchandise imports) of Agricultural raw materials and Amount of imports(as % of merchandise imports) of Food?
Provide a succinct answer. -11.45. In the year 1999, what is the difference between the Amount of imports(as % of merchandise imports) of Agricultural raw materials and Amount of imports(as % of merchandise imports) of Fuel?
Give a very brief answer. -3.95. In the year 1999, what is the difference between the Amount of imports(as % of merchandise imports) in Food and Amount of imports(as % of merchandise imports) in Fuel?
Give a very brief answer. 7.51. In the year 2000, what is the difference between the Amount of imports(as % of merchandise imports) in Agricultural raw materials and Amount of imports(as % of merchandise imports) in Food?
Keep it short and to the point. -9.78. In the year 2000, what is the difference between the Amount of imports(as % of merchandise imports) of Agricultural raw materials and Amount of imports(as % of merchandise imports) of Fuel?
Your answer should be very brief. -11.93. In the year 2000, what is the difference between the Amount of imports(as % of merchandise imports) of Food and Amount of imports(as % of merchandise imports) of Fuel?
Provide a short and direct response. -2.15. In the year 2001, what is the difference between the Amount of imports(as % of merchandise imports) in Agricultural raw materials and Amount of imports(as % of merchandise imports) in Food?
Your response must be concise. -10.41. In the year 2001, what is the difference between the Amount of imports(as % of merchandise imports) in Agricultural raw materials and Amount of imports(as % of merchandise imports) in Fuel?
Your response must be concise. -13.76. In the year 2001, what is the difference between the Amount of imports(as % of merchandise imports) in Food and Amount of imports(as % of merchandise imports) in Fuel?
Offer a terse response. -3.36. In the year 2002, what is the difference between the Amount of imports(as % of merchandise imports) in Agricultural raw materials and Amount of imports(as % of merchandise imports) in Food?
Your answer should be very brief. -11.24. In the year 2002, what is the difference between the Amount of imports(as % of merchandise imports) in Agricultural raw materials and Amount of imports(as % of merchandise imports) in Fuel?
Give a very brief answer. -12.28. In the year 2002, what is the difference between the Amount of imports(as % of merchandise imports) of Food and Amount of imports(as % of merchandise imports) of Fuel?
Offer a terse response. -1.04. What is the ratio of the Amount of imports(as % of merchandise imports) in Agricultural raw materials in 1994 to that in 1995?
Offer a very short reply. 0.95. What is the ratio of the Amount of imports(as % of merchandise imports) of Food in 1994 to that in 1995?
Keep it short and to the point. 1. What is the ratio of the Amount of imports(as % of merchandise imports) of Fuel in 1994 to that in 1995?
Your response must be concise. 1.35. What is the ratio of the Amount of imports(as % of merchandise imports) in Agricultural raw materials in 1994 to that in 1996?
Your answer should be very brief. 1.12. What is the ratio of the Amount of imports(as % of merchandise imports) of Food in 1994 to that in 1996?
Give a very brief answer. 1.06. What is the ratio of the Amount of imports(as % of merchandise imports) of Fuel in 1994 to that in 1996?
Offer a very short reply. 1.12. What is the ratio of the Amount of imports(as % of merchandise imports) of Agricultural raw materials in 1994 to that in 1997?
Your answer should be compact. 1.09. What is the ratio of the Amount of imports(as % of merchandise imports) in Food in 1994 to that in 1997?
Ensure brevity in your answer.  1.07. What is the ratio of the Amount of imports(as % of merchandise imports) of Fuel in 1994 to that in 1997?
Your response must be concise. 1.26. What is the ratio of the Amount of imports(as % of merchandise imports) of Agricultural raw materials in 1994 to that in 1998?
Your answer should be compact. 1.24. What is the ratio of the Amount of imports(as % of merchandise imports) of Food in 1994 to that in 1998?
Your response must be concise. 1.17. What is the ratio of the Amount of imports(as % of merchandise imports) of Fuel in 1994 to that in 1998?
Provide a succinct answer. 1.34. What is the ratio of the Amount of imports(as % of merchandise imports) in Agricultural raw materials in 1994 to that in 1999?
Keep it short and to the point. 1.46. What is the ratio of the Amount of imports(as % of merchandise imports) of Food in 1994 to that in 1999?
Provide a short and direct response. 1.22. What is the ratio of the Amount of imports(as % of merchandise imports) of Fuel in 1994 to that in 1999?
Your answer should be very brief. 1.77. What is the ratio of the Amount of imports(as % of merchandise imports) of Agricultural raw materials in 1994 to that in 2000?
Ensure brevity in your answer.  1.55. What is the ratio of the Amount of imports(as % of merchandise imports) in Food in 1994 to that in 2000?
Offer a very short reply. 1.41. What is the ratio of the Amount of imports(as % of merchandise imports) in Fuel in 1994 to that in 2000?
Make the answer very short. 0.73. What is the ratio of the Amount of imports(as % of merchandise imports) of Agricultural raw materials in 1994 to that in 2001?
Provide a succinct answer. 1.61. What is the ratio of the Amount of imports(as % of merchandise imports) in Food in 1994 to that in 2001?
Make the answer very short. 1.34. What is the ratio of the Amount of imports(as % of merchandise imports) in Fuel in 1994 to that in 2001?
Ensure brevity in your answer.  0.65. What is the ratio of the Amount of imports(as % of merchandise imports) in Agricultural raw materials in 1994 to that in 2002?
Offer a terse response. 1.44. What is the ratio of the Amount of imports(as % of merchandise imports) of Food in 1994 to that in 2002?
Ensure brevity in your answer.  1.24. What is the ratio of the Amount of imports(as % of merchandise imports) of Fuel in 1994 to that in 2002?
Make the answer very short. 0.71. What is the ratio of the Amount of imports(as % of merchandise imports) in Agricultural raw materials in 1995 to that in 1996?
Ensure brevity in your answer.  1.18. What is the ratio of the Amount of imports(as % of merchandise imports) of Food in 1995 to that in 1996?
Give a very brief answer. 1.06. What is the ratio of the Amount of imports(as % of merchandise imports) of Fuel in 1995 to that in 1996?
Your response must be concise. 0.83. What is the ratio of the Amount of imports(as % of merchandise imports) of Agricultural raw materials in 1995 to that in 1997?
Give a very brief answer. 1.15. What is the ratio of the Amount of imports(as % of merchandise imports) of Food in 1995 to that in 1997?
Provide a short and direct response. 1.08. What is the ratio of the Amount of imports(as % of merchandise imports) in Fuel in 1995 to that in 1997?
Provide a short and direct response. 0.93. What is the ratio of the Amount of imports(as % of merchandise imports) in Agricultural raw materials in 1995 to that in 1998?
Ensure brevity in your answer.  1.3. What is the ratio of the Amount of imports(as % of merchandise imports) of Food in 1995 to that in 1998?
Provide a short and direct response. 1.17. What is the ratio of the Amount of imports(as % of merchandise imports) in Fuel in 1995 to that in 1998?
Ensure brevity in your answer.  0.99. What is the ratio of the Amount of imports(as % of merchandise imports) in Agricultural raw materials in 1995 to that in 1999?
Offer a terse response. 1.54. What is the ratio of the Amount of imports(as % of merchandise imports) in Food in 1995 to that in 1999?
Your answer should be very brief. 1.22. What is the ratio of the Amount of imports(as % of merchandise imports) of Fuel in 1995 to that in 1999?
Provide a succinct answer. 1.31. What is the ratio of the Amount of imports(as % of merchandise imports) of Agricultural raw materials in 1995 to that in 2000?
Offer a very short reply. 1.63. What is the ratio of the Amount of imports(as % of merchandise imports) in Food in 1995 to that in 2000?
Offer a terse response. 1.41. What is the ratio of the Amount of imports(as % of merchandise imports) in Fuel in 1995 to that in 2000?
Your response must be concise. 0.54. What is the ratio of the Amount of imports(as % of merchandise imports) of Agricultural raw materials in 1995 to that in 2001?
Ensure brevity in your answer.  1.69. What is the ratio of the Amount of imports(as % of merchandise imports) in Food in 1995 to that in 2001?
Ensure brevity in your answer.  1.35. What is the ratio of the Amount of imports(as % of merchandise imports) of Fuel in 1995 to that in 2001?
Offer a very short reply. 0.48. What is the ratio of the Amount of imports(as % of merchandise imports) in Agricultural raw materials in 1995 to that in 2002?
Your answer should be compact. 1.52. What is the ratio of the Amount of imports(as % of merchandise imports) of Food in 1995 to that in 2002?
Ensure brevity in your answer.  1.24. What is the ratio of the Amount of imports(as % of merchandise imports) of Fuel in 1995 to that in 2002?
Provide a short and direct response. 0.52. What is the ratio of the Amount of imports(as % of merchandise imports) of Agricultural raw materials in 1996 to that in 1997?
Give a very brief answer. 0.97. What is the ratio of the Amount of imports(as % of merchandise imports) of Food in 1996 to that in 1997?
Your answer should be compact. 1.01. What is the ratio of the Amount of imports(as % of merchandise imports) in Fuel in 1996 to that in 1997?
Your response must be concise. 1.12. What is the ratio of the Amount of imports(as % of merchandise imports) in Agricultural raw materials in 1996 to that in 1998?
Make the answer very short. 1.1. What is the ratio of the Amount of imports(as % of merchandise imports) of Food in 1996 to that in 1998?
Offer a terse response. 1.1. What is the ratio of the Amount of imports(as % of merchandise imports) of Fuel in 1996 to that in 1998?
Your answer should be compact. 1.19. What is the ratio of the Amount of imports(as % of merchandise imports) of Agricultural raw materials in 1996 to that in 1999?
Offer a terse response. 1.3. What is the ratio of the Amount of imports(as % of merchandise imports) in Food in 1996 to that in 1999?
Ensure brevity in your answer.  1.15. What is the ratio of the Amount of imports(as % of merchandise imports) of Fuel in 1996 to that in 1999?
Keep it short and to the point. 1.58. What is the ratio of the Amount of imports(as % of merchandise imports) of Agricultural raw materials in 1996 to that in 2000?
Make the answer very short. 1.38. What is the ratio of the Amount of imports(as % of merchandise imports) in Food in 1996 to that in 2000?
Your answer should be compact. 1.33. What is the ratio of the Amount of imports(as % of merchandise imports) of Fuel in 1996 to that in 2000?
Provide a succinct answer. 0.65. What is the ratio of the Amount of imports(as % of merchandise imports) in Agricultural raw materials in 1996 to that in 2001?
Make the answer very short. 1.43. What is the ratio of the Amount of imports(as % of merchandise imports) in Food in 1996 to that in 2001?
Your answer should be very brief. 1.27. What is the ratio of the Amount of imports(as % of merchandise imports) in Fuel in 1996 to that in 2001?
Make the answer very short. 0.58. What is the ratio of the Amount of imports(as % of merchandise imports) in Agricultural raw materials in 1996 to that in 2002?
Your answer should be compact. 1.28. What is the ratio of the Amount of imports(as % of merchandise imports) in Food in 1996 to that in 2002?
Your answer should be compact. 1.17. What is the ratio of the Amount of imports(as % of merchandise imports) in Fuel in 1996 to that in 2002?
Provide a succinct answer. 0.63. What is the ratio of the Amount of imports(as % of merchandise imports) in Agricultural raw materials in 1997 to that in 1998?
Make the answer very short. 1.13. What is the ratio of the Amount of imports(as % of merchandise imports) in Food in 1997 to that in 1998?
Your answer should be very brief. 1.09. What is the ratio of the Amount of imports(as % of merchandise imports) of Fuel in 1997 to that in 1998?
Offer a terse response. 1.07. What is the ratio of the Amount of imports(as % of merchandise imports) of Agricultural raw materials in 1997 to that in 1999?
Keep it short and to the point. 1.34. What is the ratio of the Amount of imports(as % of merchandise imports) in Food in 1997 to that in 1999?
Your answer should be compact. 1.14. What is the ratio of the Amount of imports(as % of merchandise imports) of Fuel in 1997 to that in 1999?
Offer a very short reply. 1.41. What is the ratio of the Amount of imports(as % of merchandise imports) in Agricultural raw materials in 1997 to that in 2000?
Your answer should be compact. 1.42. What is the ratio of the Amount of imports(as % of merchandise imports) of Food in 1997 to that in 2000?
Provide a short and direct response. 1.31. What is the ratio of the Amount of imports(as % of merchandise imports) of Fuel in 1997 to that in 2000?
Offer a terse response. 0.58. What is the ratio of the Amount of imports(as % of merchandise imports) of Agricultural raw materials in 1997 to that in 2001?
Your response must be concise. 1.47. What is the ratio of the Amount of imports(as % of merchandise imports) of Food in 1997 to that in 2001?
Offer a terse response. 1.25. What is the ratio of the Amount of imports(as % of merchandise imports) of Fuel in 1997 to that in 2001?
Make the answer very short. 0.52. What is the ratio of the Amount of imports(as % of merchandise imports) in Agricultural raw materials in 1997 to that in 2002?
Offer a terse response. 1.32. What is the ratio of the Amount of imports(as % of merchandise imports) of Food in 1997 to that in 2002?
Offer a terse response. 1.15. What is the ratio of the Amount of imports(as % of merchandise imports) in Fuel in 1997 to that in 2002?
Give a very brief answer. 0.56. What is the ratio of the Amount of imports(as % of merchandise imports) in Agricultural raw materials in 1998 to that in 1999?
Make the answer very short. 1.18. What is the ratio of the Amount of imports(as % of merchandise imports) in Food in 1998 to that in 1999?
Offer a terse response. 1.05. What is the ratio of the Amount of imports(as % of merchandise imports) of Fuel in 1998 to that in 1999?
Give a very brief answer. 1.32. What is the ratio of the Amount of imports(as % of merchandise imports) in Agricultural raw materials in 1998 to that in 2000?
Provide a short and direct response. 1.25. What is the ratio of the Amount of imports(as % of merchandise imports) of Food in 1998 to that in 2000?
Offer a very short reply. 1.21. What is the ratio of the Amount of imports(as % of merchandise imports) of Fuel in 1998 to that in 2000?
Your answer should be compact. 0.55. What is the ratio of the Amount of imports(as % of merchandise imports) in Agricultural raw materials in 1998 to that in 2001?
Your answer should be compact. 1.3. What is the ratio of the Amount of imports(as % of merchandise imports) in Food in 1998 to that in 2001?
Your answer should be compact. 1.15. What is the ratio of the Amount of imports(as % of merchandise imports) in Fuel in 1998 to that in 2001?
Give a very brief answer. 0.48. What is the ratio of the Amount of imports(as % of merchandise imports) in Agricultural raw materials in 1998 to that in 2002?
Your answer should be compact. 1.16. What is the ratio of the Amount of imports(as % of merchandise imports) of Food in 1998 to that in 2002?
Your answer should be compact. 1.06. What is the ratio of the Amount of imports(as % of merchandise imports) of Fuel in 1998 to that in 2002?
Make the answer very short. 0.53. What is the ratio of the Amount of imports(as % of merchandise imports) of Agricultural raw materials in 1999 to that in 2000?
Your answer should be very brief. 1.06. What is the ratio of the Amount of imports(as % of merchandise imports) in Food in 1999 to that in 2000?
Give a very brief answer. 1.16. What is the ratio of the Amount of imports(as % of merchandise imports) in Fuel in 1999 to that in 2000?
Offer a very short reply. 0.41. What is the ratio of the Amount of imports(as % of merchandise imports) of Agricultural raw materials in 1999 to that in 2001?
Make the answer very short. 1.1. What is the ratio of the Amount of imports(as % of merchandise imports) in Food in 1999 to that in 2001?
Ensure brevity in your answer.  1.1. What is the ratio of the Amount of imports(as % of merchandise imports) of Fuel in 1999 to that in 2001?
Offer a terse response. 0.36. What is the ratio of the Amount of imports(as % of merchandise imports) of Agricultural raw materials in 1999 to that in 2002?
Provide a succinct answer. 0.98. What is the ratio of the Amount of imports(as % of merchandise imports) of Fuel in 1999 to that in 2002?
Your answer should be compact. 0.4. What is the ratio of the Amount of imports(as % of merchandise imports) of Agricultural raw materials in 2000 to that in 2001?
Offer a very short reply. 1.04. What is the ratio of the Amount of imports(as % of merchandise imports) of Food in 2000 to that in 2001?
Offer a very short reply. 0.95. What is the ratio of the Amount of imports(as % of merchandise imports) in Fuel in 2000 to that in 2001?
Offer a very short reply. 0.88. What is the ratio of the Amount of imports(as % of merchandise imports) of Agricultural raw materials in 2000 to that in 2002?
Provide a succinct answer. 0.93. What is the ratio of the Amount of imports(as % of merchandise imports) of Food in 2000 to that in 2002?
Make the answer very short. 0.88. What is the ratio of the Amount of imports(as % of merchandise imports) in Fuel in 2000 to that in 2002?
Ensure brevity in your answer.  0.97. What is the ratio of the Amount of imports(as % of merchandise imports) of Agricultural raw materials in 2001 to that in 2002?
Your answer should be very brief. 0.9. What is the ratio of the Amount of imports(as % of merchandise imports) in Food in 2001 to that in 2002?
Keep it short and to the point. 0.92. What is the ratio of the Amount of imports(as % of merchandise imports) in Fuel in 2001 to that in 2002?
Offer a terse response. 1.09. What is the difference between the highest and the second highest Amount of imports(as % of merchandise imports) in Agricultural raw materials?
Offer a terse response. 0.12. What is the difference between the highest and the second highest Amount of imports(as % of merchandise imports) in Food?
Keep it short and to the point. 0.04. What is the difference between the highest and the second highest Amount of imports(as % of merchandise imports) of Fuel?
Give a very brief answer. 1.31. What is the difference between the highest and the lowest Amount of imports(as % of merchandise imports) of Agricultural raw materials?
Your answer should be very brief. 1.01. What is the difference between the highest and the lowest Amount of imports(as % of merchandise imports) of Food?
Offer a terse response. 4.68. What is the difference between the highest and the lowest Amount of imports(as % of merchandise imports) of Fuel?
Your answer should be very brief. 9.67. 